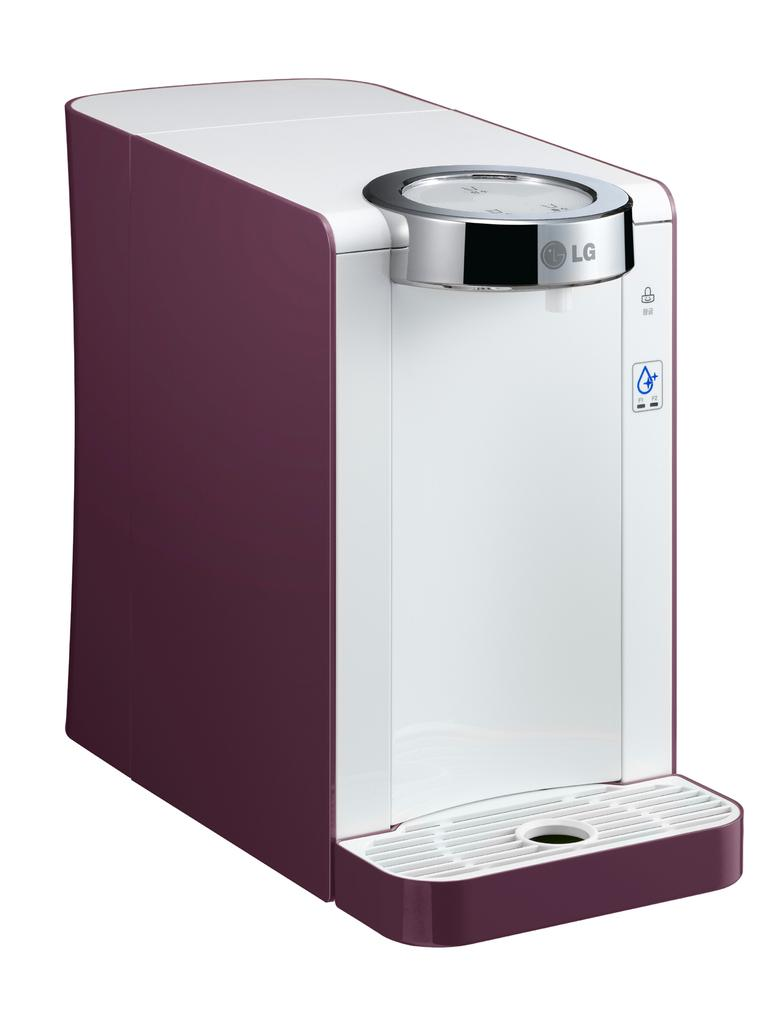<image>
Share a concise interpretation of the image provided. An appliance made by LG is maroon and white in color. 